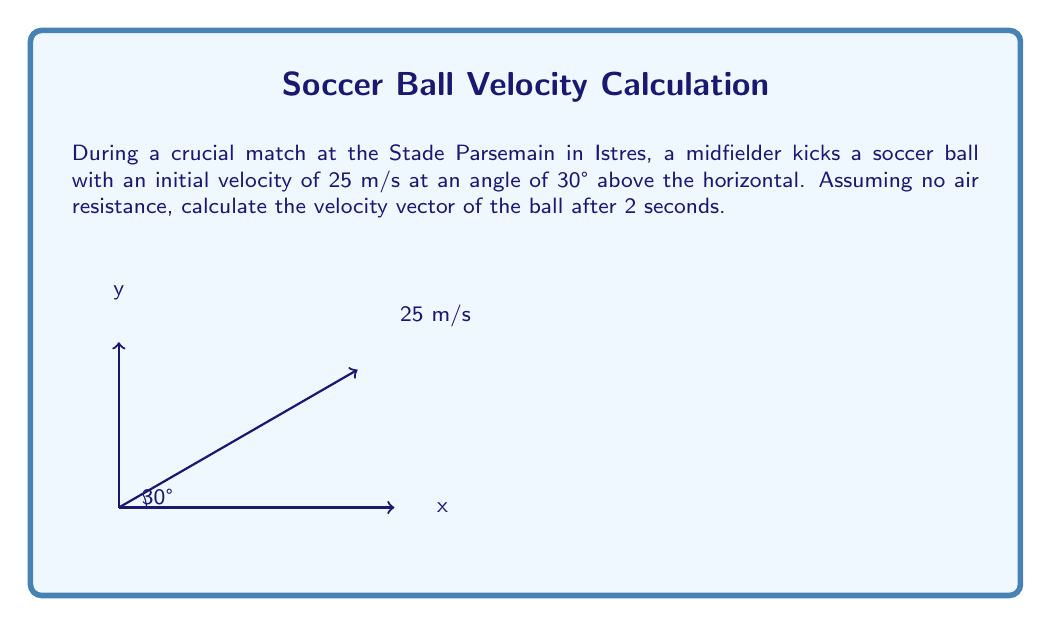Give your solution to this math problem. Let's approach this step-by-step:

1) First, we need to decompose the initial velocity into its x and y components:

   $v_{0x} = v_0 \cos \theta = 25 \cos 30° = 25 \cdot \frac{\sqrt{3}}{2} \approx 21.65$ m/s
   $v_{0y} = v_0 \sin \theta = 25 \sin 30° = 25 \cdot \frac{1}{2} = 12.5$ m/s

2) Now, we can use the equations of motion to find the x and y components of velocity after 2 seconds:

   For x-component: There's no acceleration in the x-direction, so:
   $v_x = v_{0x} = 21.65$ m/s

   For y-component: We need to consider gravitational acceleration:
   $v_y = v_{0y} - gt$, where $g = 9.8$ m/s²
   $v_y = 12.5 - 9.8 \cdot 2 = -7.1$ m/s

3) Now we have both components of the velocity vector after 2 seconds:

   $\vec{v} = (21.65, -7.1)$ m/s

4) To express this as a single vector, we can use the magnitude and direction:

   Magnitude: $|\vec{v}| = \sqrt{21.65^2 + (-7.1)^2} \approx 22.83$ m/s

   Direction: $\theta = \tan^{-1}(\frac{-7.1}{21.65}) \approx -18.15°$

Therefore, the velocity vector after 2 seconds is approximately 22.83 m/s at an angle of -18.15° to the horizontal.
Answer: $\vec{v} \approx 22.83$ m/s at $-18.15°$ to the horizontal 